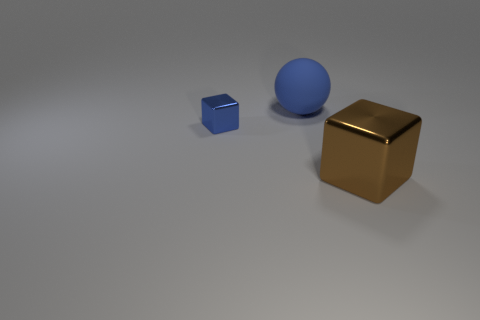Add 1 tiny blue shiny cubes. How many objects exist? 4 Subtract all cubes. How many objects are left? 1 Subtract 0 gray balls. How many objects are left? 3 Subtract all big blue matte things. Subtract all large brown objects. How many objects are left? 1 Add 2 tiny blue shiny cubes. How many tiny blue shiny cubes are left? 3 Add 1 tiny blue cubes. How many tiny blue cubes exist? 2 